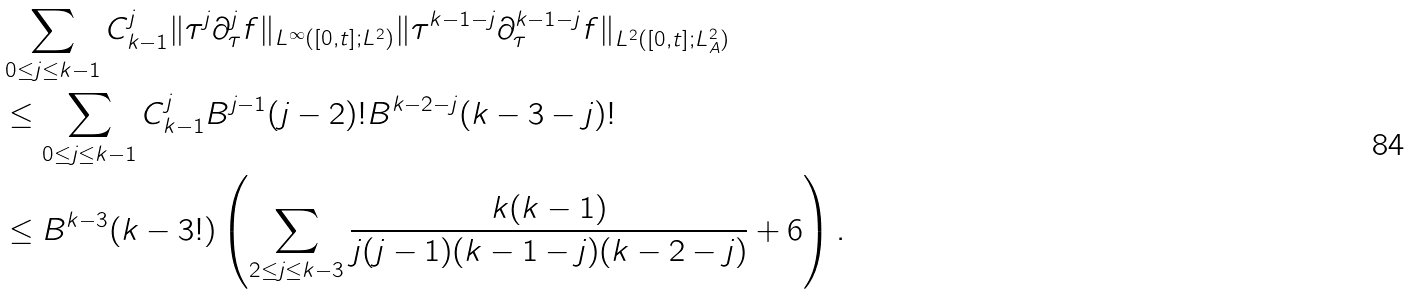<formula> <loc_0><loc_0><loc_500><loc_500>& \sum _ { 0 \leq j \leq k - 1 } C ^ { j } _ { k - 1 } \| \tau ^ { j } \partial ^ { j } _ { \tau } f \| _ { L ^ { \infty } ( [ 0 , t ] ; L ^ { 2 } ) } \| \tau ^ { k - 1 - j } \partial ^ { k - 1 - j } _ { \tau } f \| _ { L ^ { 2 } ( [ 0 , t ] ; L ^ { 2 } _ { A } ) } \\ & \leq \sum _ { 0 \leq j \leq k - 1 } C ^ { j } _ { k - 1 } B ^ { j - 1 } ( j - 2 ) ! B ^ { k - 2 - j } ( k - 3 - j ) ! \\ & \leq B ^ { k - 3 } ( k - 3 ! ) \left ( \sum _ { 2 \leq j \leq k - 3 } \frac { k ( k - 1 ) } { j ( j - 1 ) ( k - 1 - j ) ( k - 2 - j ) } + 6 \right ) .</formula> 